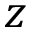Convert formula to latex. <formula><loc_0><loc_0><loc_500><loc_500>z</formula> 